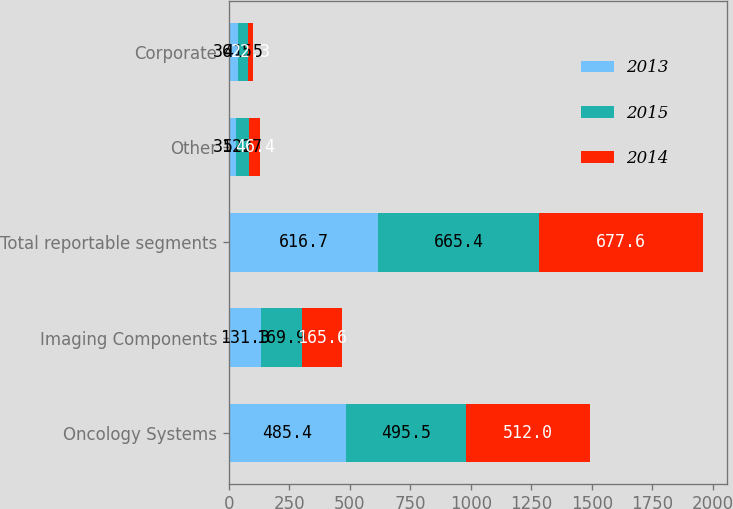Convert chart to OTSL. <chart><loc_0><loc_0><loc_500><loc_500><stacked_bar_chart><ecel><fcel>Oncology Systems<fcel>Imaging Components<fcel>Total reportable segments<fcel>Other<fcel>Corporate<nl><fcel>2013<fcel>485.4<fcel>131.3<fcel>616.7<fcel>31.2<fcel>36.5<nl><fcel>2015<fcel>495.5<fcel>169.9<fcel>665.4<fcel>52.7<fcel>41.5<nl><fcel>2014<fcel>512<fcel>165.6<fcel>677.6<fcel>46.4<fcel>22.3<nl></chart> 